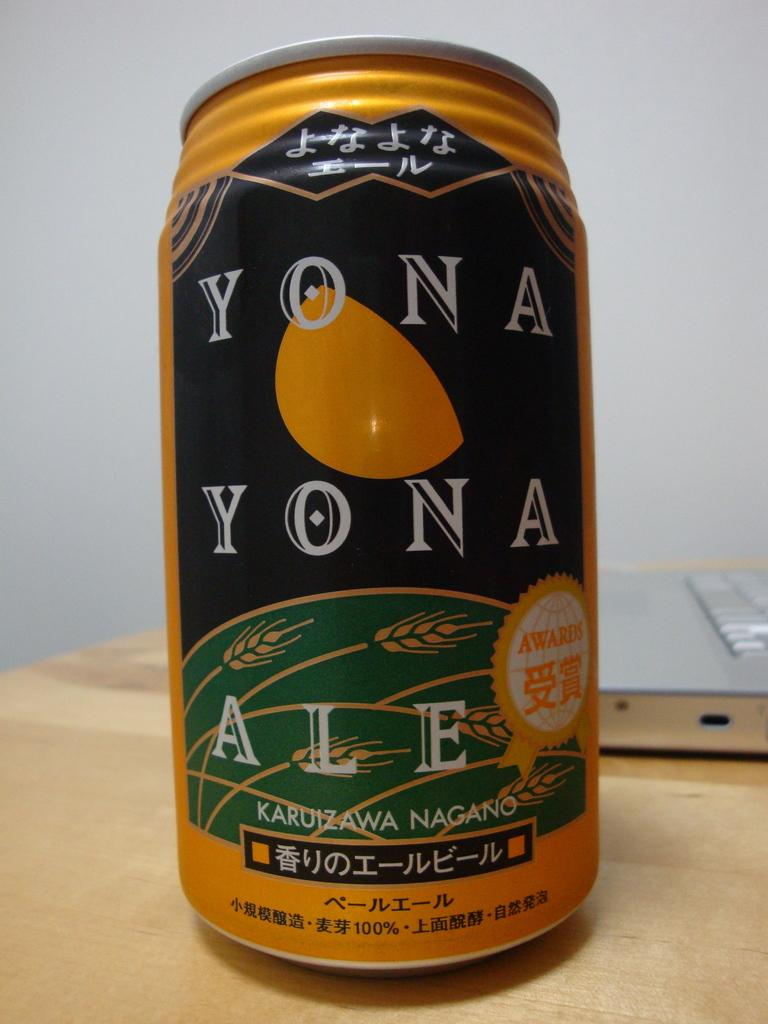What type of beverage container is in the image? There is a coke tin in the image. Where is the coke tin located? The coke tin is on a table. What electronic device is also visible in the image? There is a laptop in the image. How is the laptop positioned in relation to the coke tin? The laptop is behind the coke tin. What type of nose can be seen on the rat in the image? There is no rat present in the image, so there is no nose to describe. 